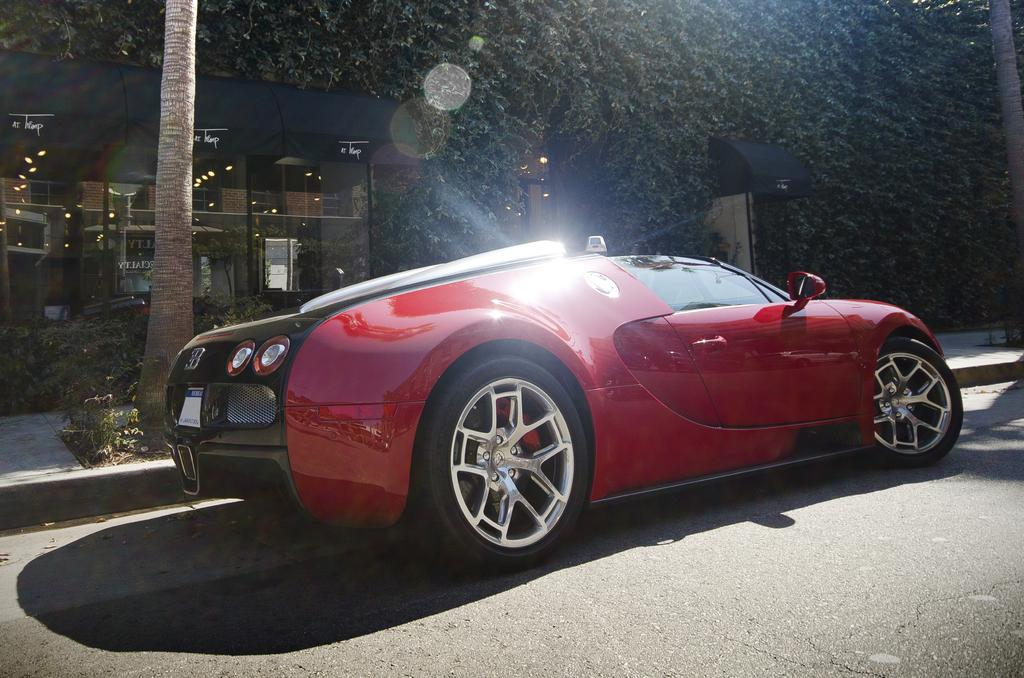What type of structure is visible in the image? There is a building in the image. What type of vegetation is present near the building? There are wall shrubs and plants in the image. What mode of transportation can be seen on the road in the image? There is a car on the road in the image. What type of signage is present in the image? There are boards with text in the image. What type of suit is the person wearing while walking to the event in the image? There are no people, suits, or events present in the image. 